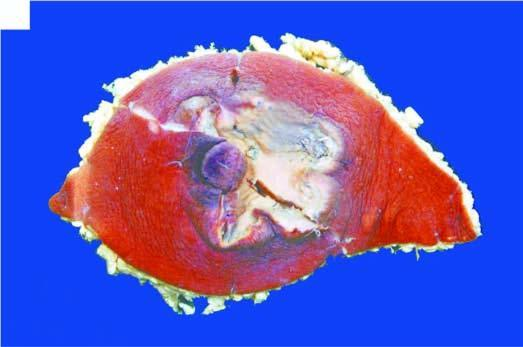s stanford type crusted and ulcerated?
Answer the question using a single word or phrase. No 